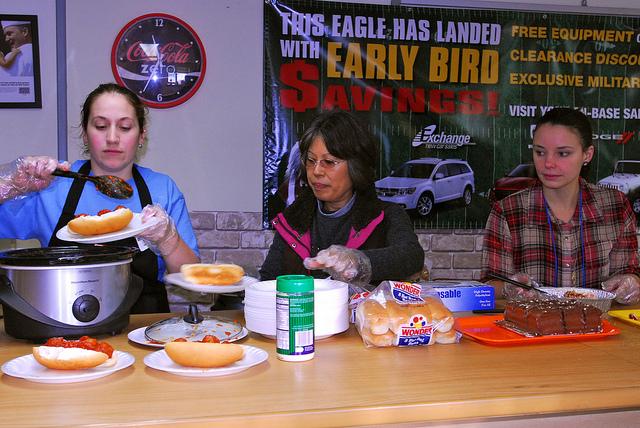Are the people pictured eating together?
Concise answer only. Yes. Who is in a blue shirt?
Concise answer only. Woman. Are there any men?
Keep it brief. No. 